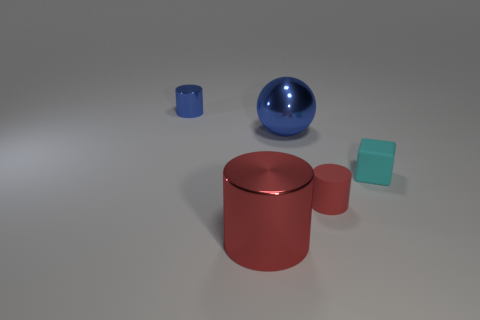Subtract all red spheres. How many red cylinders are left? 2 Add 1 small rubber blocks. How many objects exist? 6 Subtract all cylinders. How many objects are left? 2 Subtract all tiny green shiny cubes. Subtract all rubber things. How many objects are left? 3 Add 1 tiny metal cylinders. How many tiny metal cylinders are left? 2 Add 5 small blue metal cylinders. How many small blue metal cylinders exist? 6 Subtract 0 purple balls. How many objects are left? 5 